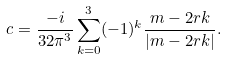Convert formula to latex. <formula><loc_0><loc_0><loc_500><loc_500>c = \frac { - i } { 3 2 \pi ^ { 3 } } \sum _ { k = 0 } ^ { 3 } ( - 1 ) ^ { k } \frac { m - 2 r k } { \left | m - 2 r k \right | } .</formula> 